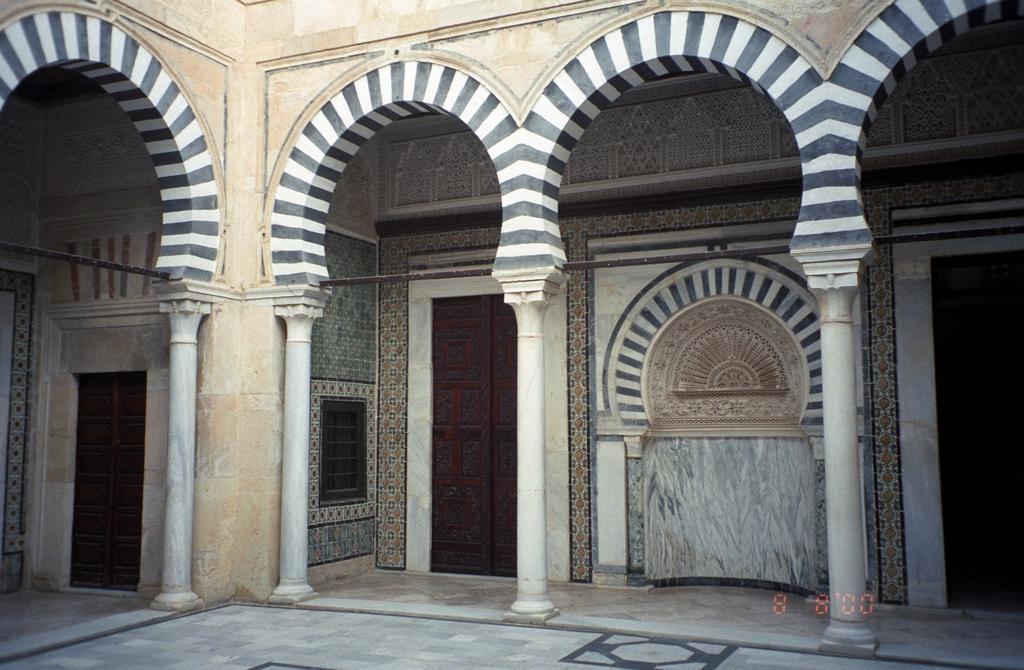How would you summarize this image in a sentence or two? Here in this picture we can see pillars present and we can also see arch like structures present on the building and we can see doors present. 